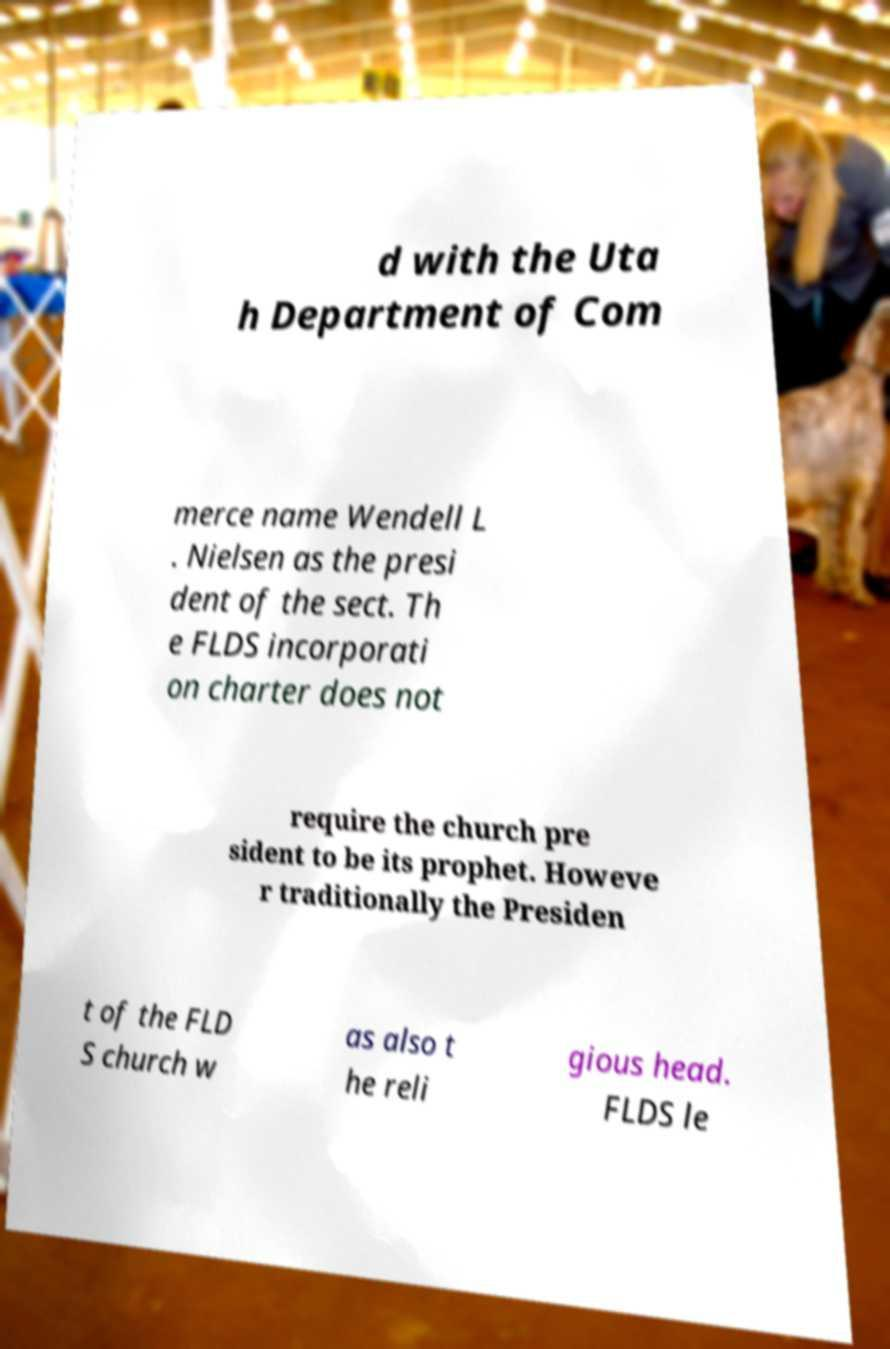For documentation purposes, I need the text within this image transcribed. Could you provide that? d with the Uta h Department of Com merce name Wendell L . Nielsen as the presi dent of the sect. Th e FLDS incorporati on charter does not require the church pre sident to be its prophet. Howeve r traditionally the Presiden t of the FLD S church w as also t he reli gious head. FLDS le 